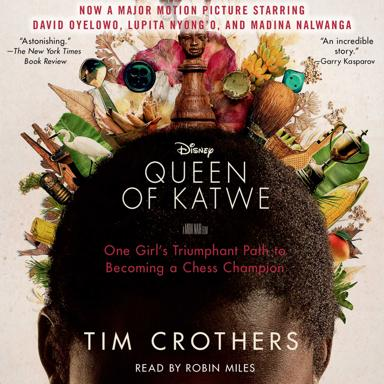What is the name of the major motion picture mentioned in the image?
 The name of the major motion picture is "Queen of Katwe." Who are the main actors in the movie "Queen of Katwe"? The main actors in the movie "Queen of Katwe" are David Oyelowo, Lupita Nyong'o, and Madina Nalwanga. What is the movie "Queen of Katwe" about? The movie "Queen of Katwe" is about one girl's triumphant path to becoming a chess champion. 